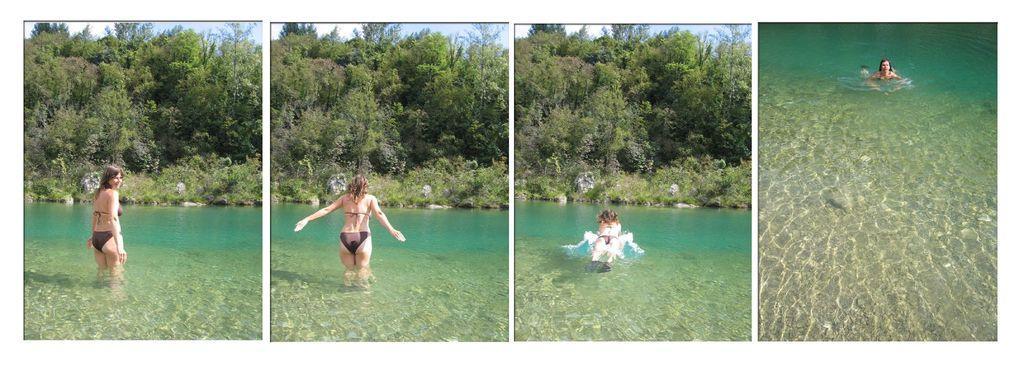Could you give a brief overview of what you see in this image? This is a collage picture and in this picture we can see a woman standing and swimming in the water and in the background we can see trees, sky. 